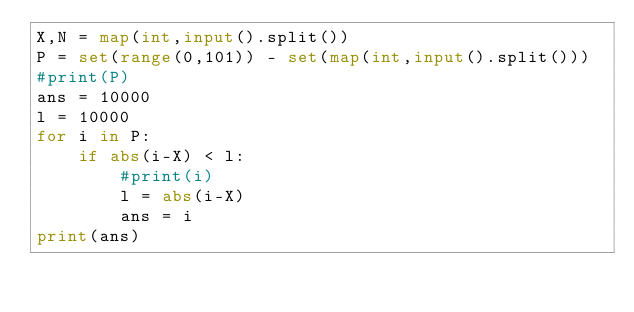<code> <loc_0><loc_0><loc_500><loc_500><_Python_>X,N = map(int,input().split())
P = set(range(0,101)) - set(map(int,input().split()))
#print(P)
ans = 10000
l = 10000
for i in P:
    if abs(i-X) < l:
        #print(i)
        l = abs(i-X)
        ans = i
print(ans)</code> 